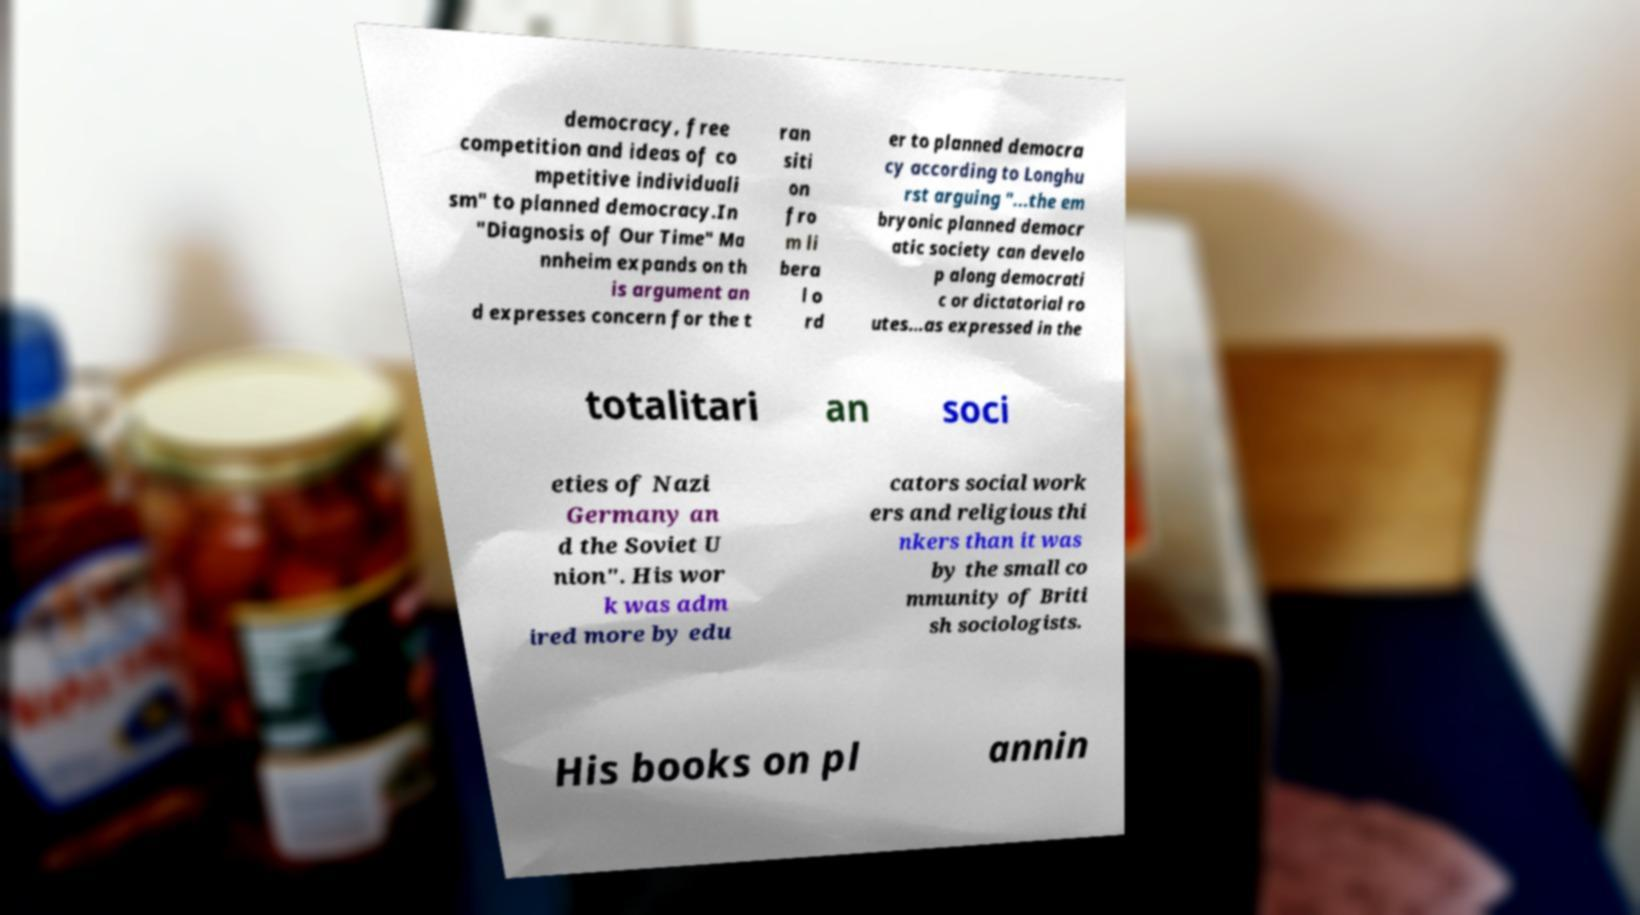Could you extract and type out the text from this image? democracy, free competition and ideas of co mpetitive individuali sm" to planned democracy.In "Diagnosis of Our Time" Ma nnheim expands on th is argument an d expresses concern for the t ran siti on fro m li bera l o rd er to planned democra cy according to Longhu rst arguing "...the em bryonic planned democr atic society can develo p along democrati c or dictatorial ro utes...as expressed in the totalitari an soci eties of Nazi Germany an d the Soviet U nion". His wor k was adm ired more by edu cators social work ers and religious thi nkers than it was by the small co mmunity of Briti sh sociologists. His books on pl annin 